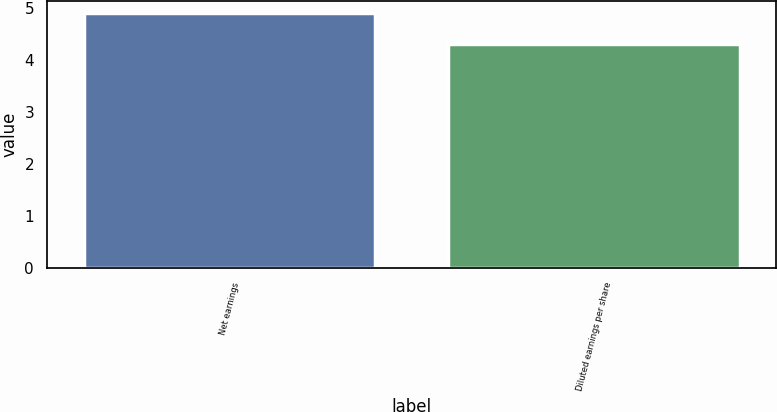<chart> <loc_0><loc_0><loc_500><loc_500><bar_chart><fcel>Net earnings<fcel>Diluted earnings per share<nl><fcel>4.9<fcel>4.3<nl></chart> 